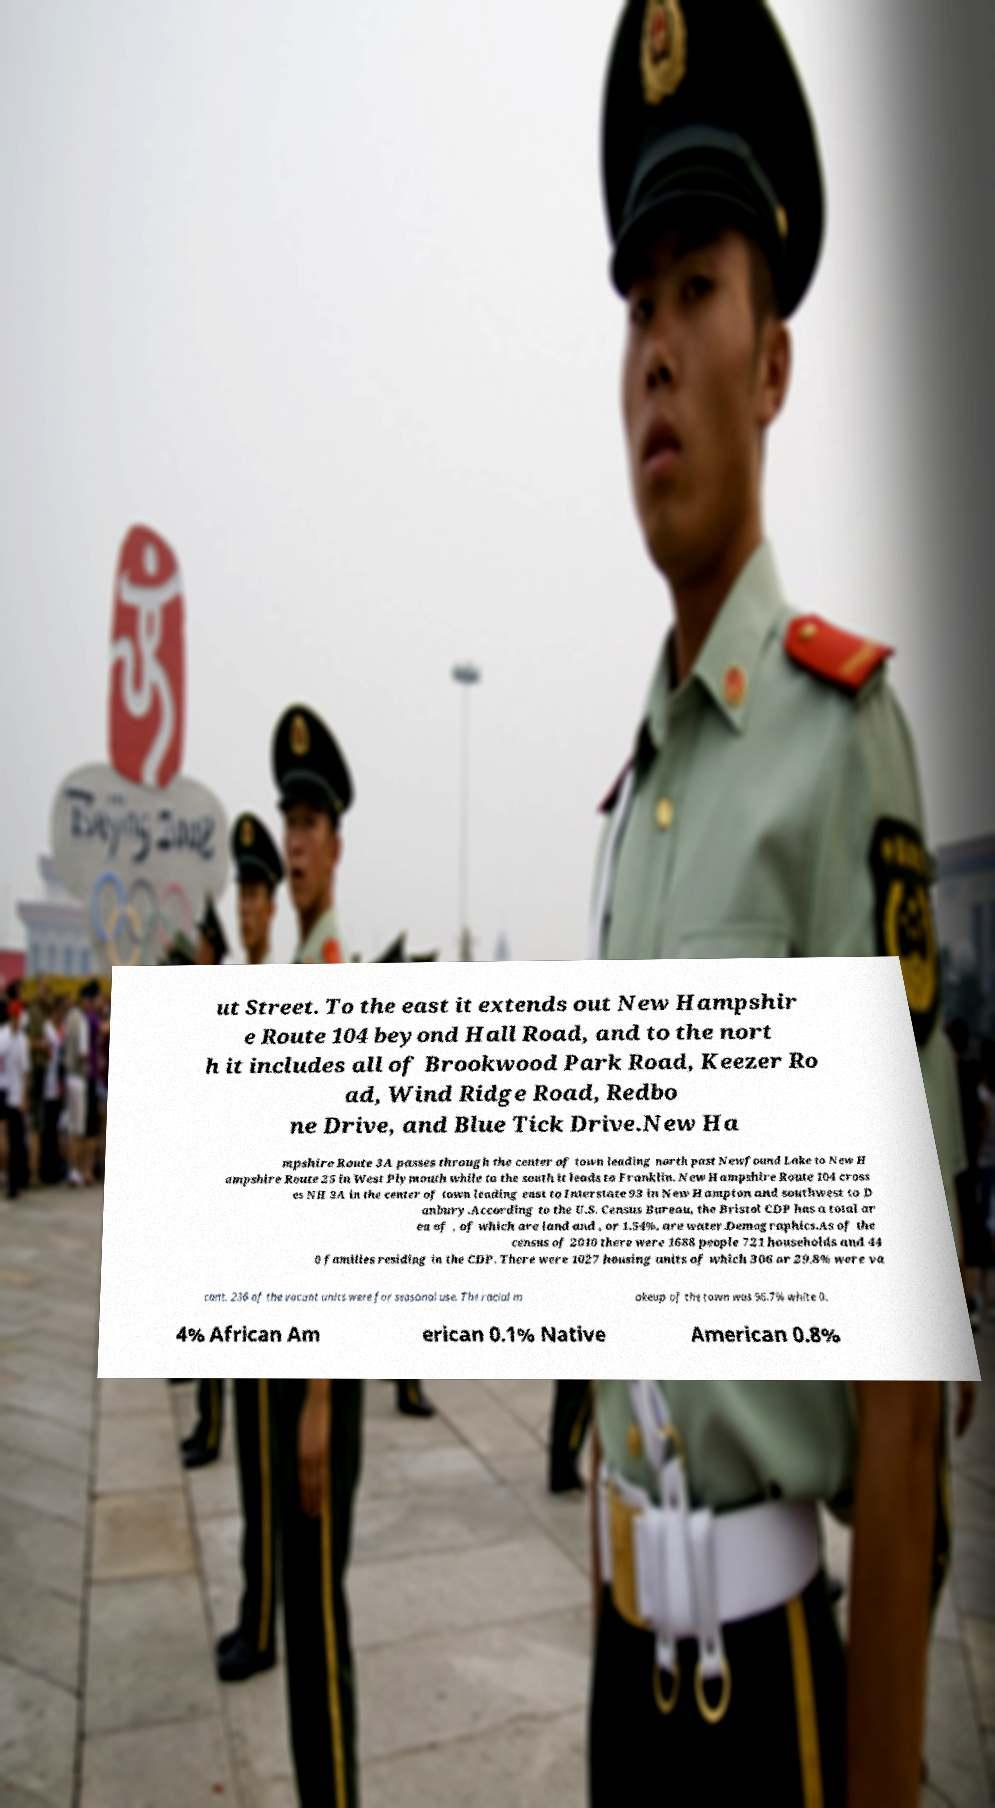Please identify and transcribe the text found in this image. ut Street. To the east it extends out New Hampshir e Route 104 beyond Hall Road, and to the nort h it includes all of Brookwood Park Road, Keezer Ro ad, Wind Ridge Road, Redbo ne Drive, and Blue Tick Drive.New Ha mpshire Route 3A passes through the center of town leading north past Newfound Lake to New H ampshire Route 25 in West Plymouth while to the south it leads to Franklin. New Hampshire Route 104 cross es NH 3A in the center of town leading east to Interstate 93 in New Hampton and southwest to D anbury.According to the U.S. Census Bureau, the Bristol CDP has a total ar ea of , of which are land and , or 1.54%, are water.Demographics.As of the census of 2010 there were 1688 people 721 households and 44 0 families residing in the CDP. There were 1027 housing units of which 306 or 29.8% were va cant. 236 of the vacant units were for seasonal use. The racial m akeup of the town was 96.7% white 0. 4% African Am erican 0.1% Native American 0.8% 